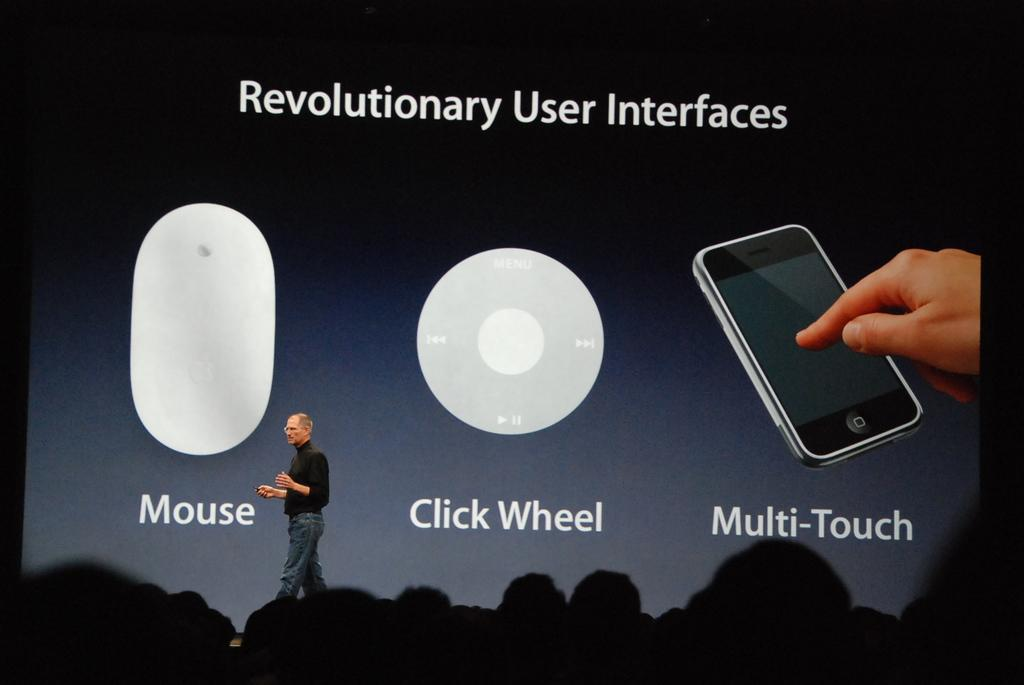Provide a one-sentence caption for the provided image. Shows the mouse or click wheel part of a multi touch phone. 